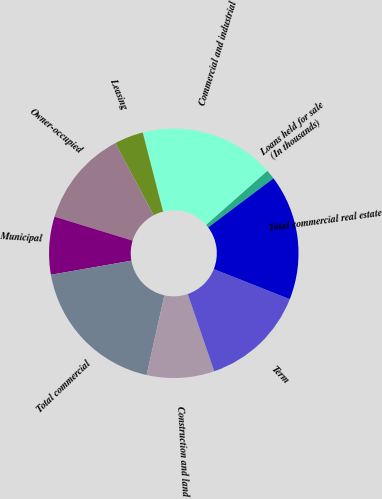Convert chart. <chart><loc_0><loc_0><loc_500><loc_500><pie_chart><fcel>(In thousands)<fcel>Loans held for sale<fcel>Commercial and industrial<fcel>Leasing<fcel>Owner-occupied<fcel>Municipal<fcel>Total commercial<fcel>Construction and land<fcel>Term<fcel>Total commercial real estate<nl><fcel>0.0%<fcel>1.25%<fcel>17.5%<fcel>3.75%<fcel>12.5%<fcel>7.5%<fcel>18.75%<fcel>8.75%<fcel>13.75%<fcel>16.25%<nl></chart> 